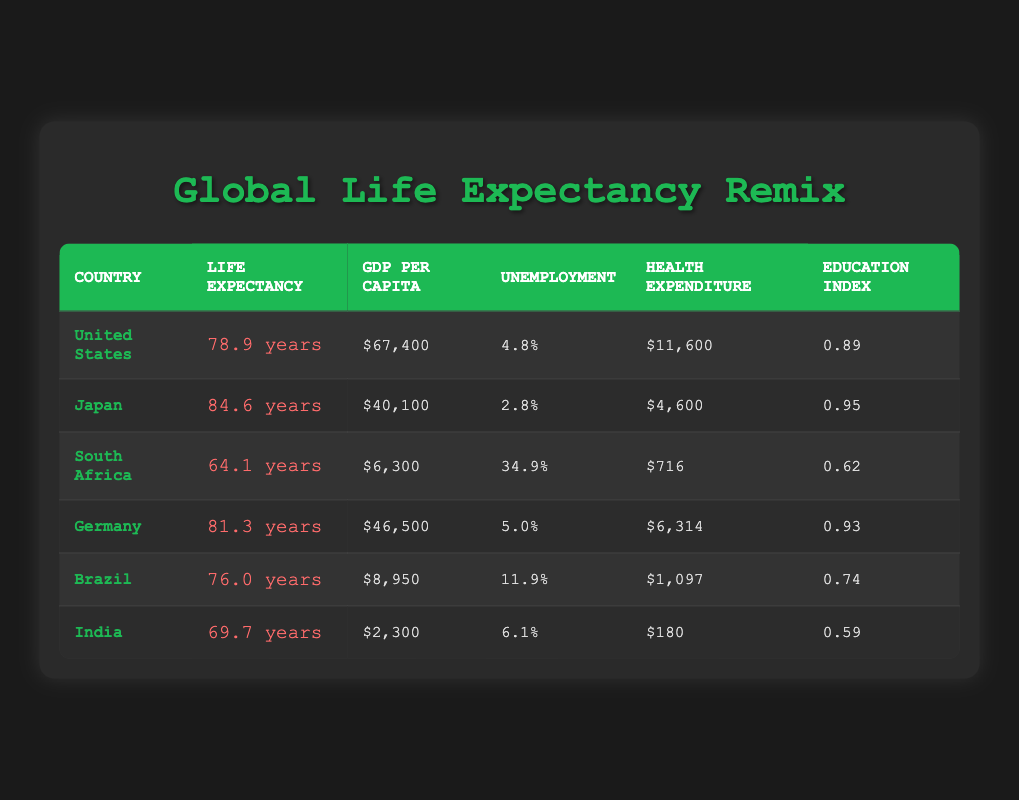What is the average life expectancy of the countries listed? To find the average life expectancy, add the life expectancies: (78.9 + 84.6 + 64.1 + 81.3 + 76.0 + 69.7) = 455.6 years. Then, divide by the number of countries, which is 6: 455.6 / 6 = 75.93.
Answer: 75.93 years Which country has the highest GDP per capita? Looking through the GDP Per Capita column, Japan has the highest value at $40,100 compared to other countries listed.
Answer: Japan Is the average life expectancy higher in Germany or Brazil? Germany has an average life expectancy of 81.3 years, while Brazil has 76.0 years. Thus, Germany has a higher life expectancy than Brazil.
Answer: Yes How much does health expenditure per capita differ between the United States and South Africa? Subtract South Africa's health expenditure ($716) from the United States' expenditure ($11,600): $11,600 - $716 = $10,884.
Answer: $10,884 Does India have the lowest education index among the countries listed? From the Education Index column, India has an index of 0.59, which is lower than all other countries listed.
Answer: Yes What is the overall unemployment rate for the countries currently listed? To find the overall unemployment rate, we calculate the average: (4.8 + 2.8 + 34.9 + 5.0 + 11.9 + 6.1) = 65.5%. Dividing by the number of countries (6) gives: 65.5 / 6 = 10.92%.
Answer: 10.92% Which country has the least health expenditure per capita? By checking the Health Expenditure Per Capita column, India has the lowest value at $180 compared to other countries.
Answer: India Is there a correlation between GDP per capita and life expectancy in the data? A quick observation shows that higher GDP per capita generally corresponds with higher life expectancy, such as Japan and the U.S. having higher values and longer life spans, suggesting a positive correlation.
Answer: Yes 